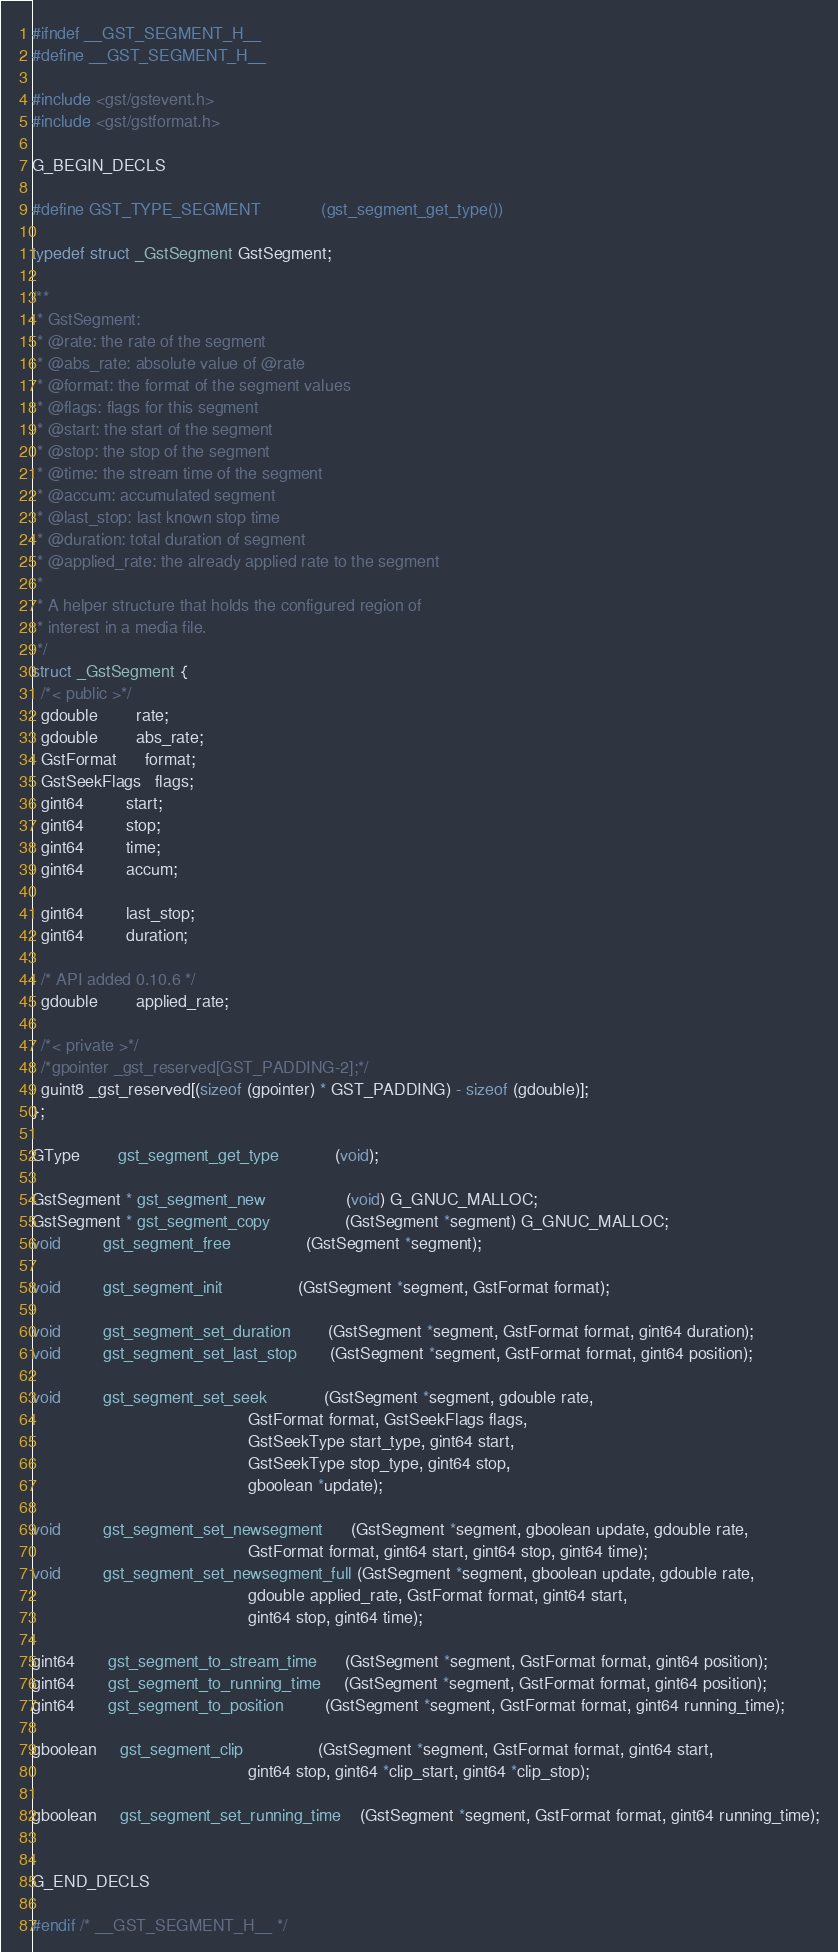<code> <loc_0><loc_0><loc_500><loc_500><_C_>

#ifndef __GST_SEGMENT_H__
#define __GST_SEGMENT_H__

#include <gst/gstevent.h>
#include <gst/gstformat.h>

G_BEGIN_DECLS

#define GST_TYPE_SEGMENT             (gst_segment_get_type())

typedef struct _GstSegment GstSegment;

/**
 * GstSegment:
 * @rate: the rate of the segment
 * @abs_rate: absolute value of @rate
 * @format: the format of the segment values
 * @flags: flags for this segment
 * @start: the start of the segment
 * @stop: the stop of the segment
 * @time: the stream time of the segment
 * @accum: accumulated segment
 * @last_stop: last known stop time
 * @duration: total duration of segment
 * @applied_rate: the already applied rate to the segment
 *
 * A helper structure that holds the configured region of
 * interest in a media file.
 */
struct _GstSegment {
  /*< public >*/
  gdouble        rate;
  gdouble        abs_rate;
  GstFormat      format;
  GstSeekFlags   flags;
  gint64         start;
  gint64         stop;
  gint64         time;
  gint64         accum;

  gint64         last_stop;
  gint64         duration;

  /* API added 0.10.6 */
  gdouble        applied_rate;

  /*< private >*/
  /*gpointer _gst_reserved[GST_PADDING-2];*/
  guint8 _gst_reserved[(sizeof (gpointer) * GST_PADDING) - sizeof (gdouble)];
};

GType        gst_segment_get_type            (void);

GstSegment * gst_segment_new                 (void) G_GNUC_MALLOC;
GstSegment * gst_segment_copy                (GstSegment *segment) G_GNUC_MALLOC;
void         gst_segment_free                (GstSegment *segment);

void         gst_segment_init                (GstSegment *segment, GstFormat format);

void         gst_segment_set_duration        (GstSegment *segment, GstFormat format, gint64 duration);
void         gst_segment_set_last_stop       (GstSegment *segment, GstFormat format, gint64 position);

void         gst_segment_set_seek            (GstSegment *segment, gdouble rate,
                                              GstFormat format, GstSeekFlags flags,
                                              GstSeekType start_type, gint64 start,
                                              GstSeekType stop_type, gint64 stop,
                                              gboolean *update);

void         gst_segment_set_newsegment      (GstSegment *segment, gboolean update, gdouble rate,
                                              GstFormat format, gint64 start, gint64 stop, gint64 time);
void         gst_segment_set_newsegment_full (GstSegment *segment, gboolean update, gdouble rate,
                                              gdouble applied_rate, GstFormat format, gint64 start,
                                              gint64 stop, gint64 time);

gint64       gst_segment_to_stream_time      (GstSegment *segment, GstFormat format, gint64 position);
gint64       gst_segment_to_running_time     (GstSegment *segment, GstFormat format, gint64 position);
gint64       gst_segment_to_position         (GstSegment *segment, GstFormat format, gint64 running_time);

gboolean     gst_segment_clip                (GstSegment *segment, GstFormat format, gint64 start,
                                              gint64 stop, gint64 *clip_start, gint64 *clip_stop);

gboolean     gst_segment_set_running_time    (GstSegment *segment, GstFormat format, gint64 running_time);


G_END_DECLS

#endif /* __GST_SEGMENT_H__ */
</code> 